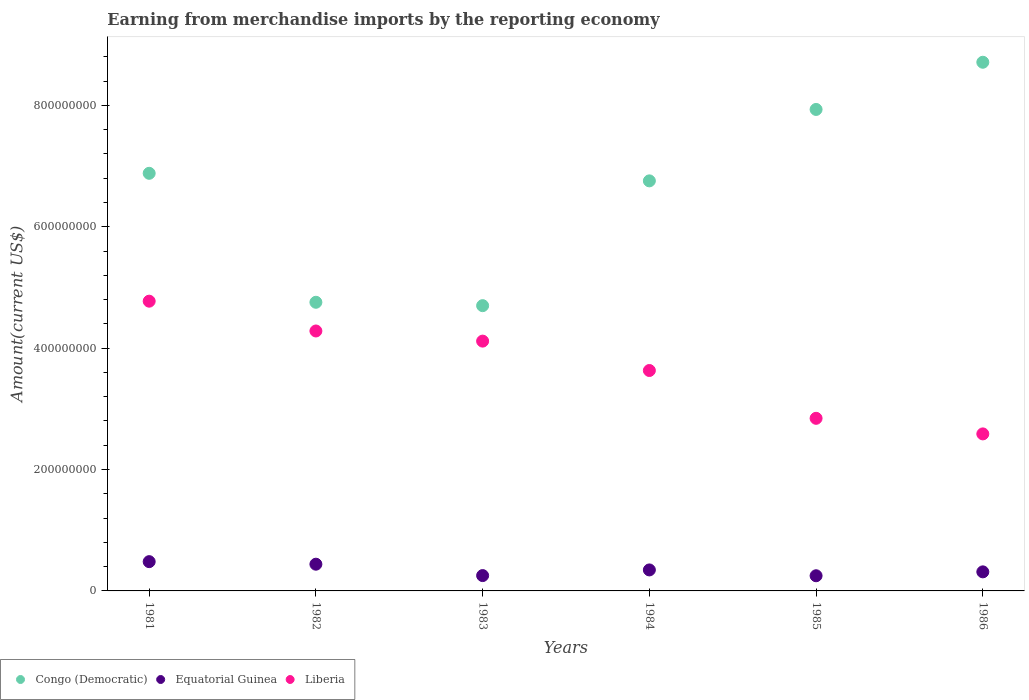Is the number of dotlines equal to the number of legend labels?
Give a very brief answer. Yes. What is the amount earned from merchandise imports in Liberia in 1984?
Your answer should be very brief. 3.63e+08. Across all years, what is the maximum amount earned from merchandise imports in Equatorial Guinea?
Keep it short and to the point. 4.82e+07. Across all years, what is the minimum amount earned from merchandise imports in Liberia?
Offer a terse response. 2.59e+08. In which year was the amount earned from merchandise imports in Equatorial Guinea maximum?
Offer a terse response. 1981. In which year was the amount earned from merchandise imports in Liberia minimum?
Keep it short and to the point. 1986. What is the total amount earned from merchandise imports in Liberia in the graph?
Your response must be concise. 2.22e+09. What is the difference between the amount earned from merchandise imports in Liberia in 1982 and that in 1985?
Your answer should be compact. 1.44e+08. What is the difference between the amount earned from merchandise imports in Equatorial Guinea in 1985 and the amount earned from merchandise imports in Congo (Democratic) in 1981?
Your response must be concise. -6.63e+08. What is the average amount earned from merchandise imports in Equatorial Guinea per year?
Your response must be concise. 3.48e+07. In the year 1983, what is the difference between the amount earned from merchandise imports in Liberia and amount earned from merchandise imports in Equatorial Guinea?
Your response must be concise. 3.86e+08. What is the ratio of the amount earned from merchandise imports in Liberia in 1983 to that in 1984?
Your answer should be compact. 1.13. What is the difference between the highest and the second highest amount earned from merchandise imports in Equatorial Guinea?
Your answer should be compact. 4.21e+06. What is the difference between the highest and the lowest amount earned from merchandise imports in Congo (Democratic)?
Keep it short and to the point. 4.01e+08. Is the sum of the amount earned from merchandise imports in Equatorial Guinea in 1982 and 1983 greater than the maximum amount earned from merchandise imports in Liberia across all years?
Provide a succinct answer. No. Is it the case that in every year, the sum of the amount earned from merchandise imports in Liberia and amount earned from merchandise imports in Congo (Democratic)  is greater than the amount earned from merchandise imports in Equatorial Guinea?
Give a very brief answer. Yes. Does the amount earned from merchandise imports in Equatorial Guinea monotonically increase over the years?
Offer a very short reply. No. Is the amount earned from merchandise imports in Equatorial Guinea strictly greater than the amount earned from merchandise imports in Liberia over the years?
Provide a succinct answer. No. How many dotlines are there?
Offer a very short reply. 3. Does the graph contain grids?
Offer a very short reply. No. Where does the legend appear in the graph?
Offer a terse response. Bottom left. How many legend labels are there?
Your answer should be compact. 3. How are the legend labels stacked?
Offer a terse response. Horizontal. What is the title of the graph?
Your response must be concise. Earning from merchandise imports by the reporting economy. What is the label or title of the Y-axis?
Offer a very short reply. Amount(current US$). What is the Amount(current US$) in Congo (Democratic) in 1981?
Give a very brief answer. 6.88e+08. What is the Amount(current US$) in Equatorial Guinea in 1981?
Provide a succinct answer. 4.82e+07. What is the Amount(current US$) in Liberia in 1981?
Your response must be concise. 4.77e+08. What is the Amount(current US$) of Congo (Democratic) in 1982?
Give a very brief answer. 4.76e+08. What is the Amount(current US$) in Equatorial Guinea in 1982?
Your response must be concise. 4.40e+07. What is the Amount(current US$) in Liberia in 1982?
Make the answer very short. 4.28e+08. What is the Amount(current US$) in Congo (Democratic) in 1983?
Keep it short and to the point. 4.70e+08. What is the Amount(current US$) in Equatorial Guinea in 1983?
Keep it short and to the point. 2.53e+07. What is the Amount(current US$) of Liberia in 1983?
Offer a terse response. 4.12e+08. What is the Amount(current US$) in Congo (Democratic) in 1984?
Provide a short and direct response. 6.76e+08. What is the Amount(current US$) of Equatorial Guinea in 1984?
Your answer should be very brief. 3.46e+07. What is the Amount(current US$) of Liberia in 1984?
Ensure brevity in your answer.  3.63e+08. What is the Amount(current US$) of Congo (Democratic) in 1985?
Offer a terse response. 7.93e+08. What is the Amount(current US$) in Equatorial Guinea in 1985?
Give a very brief answer. 2.50e+07. What is the Amount(current US$) in Liberia in 1985?
Make the answer very short. 2.84e+08. What is the Amount(current US$) of Congo (Democratic) in 1986?
Offer a very short reply. 8.71e+08. What is the Amount(current US$) in Equatorial Guinea in 1986?
Your response must be concise. 3.14e+07. What is the Amount(current US$) in Liberia in 1986?
Your answer should be compact. 2.59e+08. Across all years, what is the maximum Amount(current US$) in Congo (Democratic)?
Provide a short and direct response. 8.71e+08. Across all years, what is the maximum Amount(current US$) in Equatorial Guinea?
Your answer should be very brief. 4.82e+07. Across all years, what is the maximum Amount(current US$) in Liberia?
Offer a terse response. 4.77e+08. Across all years, what is the minimum Amount(current US$) of Congo (Democratic)?
Your answer should be very brief. 4.70e+08. Across all years, what is the minimum Amount(current US$) in Equatorial Guinea?
Your answer should be compact. 2.50e+07. Across all years, what is the minimum Amount(current US$) of Liberia?
Your response must be concise. 2.59e+08. What is the total Amount(current US$) of Congo (Democratic) in the graph?
Make the answer very short. 3.97e+09. What is the total Amount(current US$) in Equatorial Guinea in the graph?
Provide a short and direct response. 2.09e+08. What is the total Amount(current US$) of Liberia in the graph?
Offer a very short reply. 2.22e+09. What is the difference between the Amount(current US$) in Congo (Democratic) in 1981 and that in 1982?
Provide a succinct answer. 2.12e+08. What is the difference between the Amount(current US$) in Equatorial Guinea in 1981 and that in 1982?
Offer a very short reply. 4.21e+06. What is the difference between the Amount(current US$) in Liberia in 1981 and that in 1982?
Your answer should be compact. 4.91e+07. What is the difference between the Amount(current US$) in Congo (Democratic) in 1981 and that in 1983?
Keep it short and to the point. 2.18e+08. What is the difference between the Amount(current US$) in Equatorial Guinea in 1981 and that in 1983?
Give a very brief answer. 2.30e+07. What is the difference between the Amount(current US$) of Liberia in 1981 and that in 1983?
Your answer should be very brief. 6.58e+07. What is the difference between the Amount(current US$) of Congo (Democratic) in 1981 and that in 1984?
Make the answer very short. 1.24e+07. What is the difference between the Amount(current US$) in Equatorial Guinea in 1981 and that in 1984?
Ensure brevity in your answer.  1.37e+07. What is the difference between the Amount(current US$) in Liberia in 1981 and that in 1984?
Offer a very short reply. 1.14e+08. What is the difference between the Amount(current US$) in Congo (Democratic) in 1981 and that in 1985?
Provide a succinct answer. -1.05e+08. What is the difference between the Amount(current US$) of Equatorial Guinea in 1981 and that in 1985?
Your answer should be compact. 2.33e+07. What is the difference between the Amount(current US$) in Liberia in 1981 and that in 1985?
Your answer should be compact. 1.93e+08. What is the difference between the Amount(current US$) in Congo (Democratic) in 1981 and that in 1986?
Ensure brevity in your answer.  -1.83e+08. What is the difference between the Amount(current US$) in Equatorial Guinea in 1981 and that in 1986?
Offer a terse response. 1.68e+07. What is the difference between the Amount(current US$) of Liberia in 1981 and that in 1986?
Your answer should be compact. 2.19e+08. What is the difference between the Amount(current US$) of Congo (Democratic) in 1982 and that in 1983?
Ensure brevity in your answer.  5.57e+06. What is the difference between the Amount(current US$) in Equatorial Guinea in 1982 and that in 1983?
Your answer should be compact. 1.88e+07. What is the difference between the Amount(current US$) in Liberia in 1982 and that in 1983?
Make the answer very short. 1.67e+07. What is the difference between the Amount(current US$) of Congo (Democratic) in 1982 and that in 1984?
Your response must be concise. -2.00e+08. What is the difference between the Amount(current US$) of Equatorial Guinea in 1982 and that in 1984?
Offer a terse response. 9.44e+06. What is the difference between the Amount(current US$) in Liberia in 1982 and that in 1984?
Give a very brief answer. 6.51e+07. What is the difference between the Amount(current US$) in Congo (Democratic) in 1982 and that in 1985?
Keep it short and to the point. -3.18e+08. What is the difference between the Amount(current US$) of Equatorial Guinea in 1982 and that in 1985?
Your answer should be very brief. 1.90e+07. What is the difference between the Amount(current US$) in Liberia in 1982 and that in 1985?
Offer a terse response. 1.44e+08. What is the difference between the Amount(current US$) of Congo (Democratic) in 1982 and that in 1986?
Provide a succinct answer. -3.95e+08. What is the difference between the Amount(current US$) of Equatorial Guinea in 1982 and that in 1986?
Provide a succinct answer. 1.26e+07. What is the difference between the Amount(current US$) of Liberia in 1982 and that in 1986?
Your response must be concise. 1.70e+08. What is the difference between the Amount(current US$) of Congo (Democratic) in 1983 and that in 1984?
Give a very brief answer. -2.06e+08. What is the difference between the Amount(current US$) of Equatorial Guinea in 1983 and that in 1984?
Offer a terse response. -9.32e+06. What is the difference between the Amount(current US$) in Liberia in 1983 and that in 1984?
Your answer should be very brief. 4.84e+07. What is the difference between the Amount(current US$) in Congo (Democratic) in 1983 and that in 1985?
Your answer should be compact. -3.23e+08. What is the difference between the Amount(current US$) in Equatorial Guinea in 1983 and that in 1985?
Offer a very short reply. 2.85e+05. What is the difference between the Amount(current US$) in Liberia in 1983 and that in 1985?
Ensure brevity in your answer.  1.27e+08. What is the difference between the Amount(current US$) in Congo (Democratic) in 1983 and that in 1986?
Give a very brief answer. -4.01e+08. What is the difference between the Amount(current US$) of Equatorial Guinea in 1983 and that in 1986?
Make the answer very short. -6.14e+06. What is the difference between the Amount(current US$) of Liberia in 1983 and that in 1986?
Keep it short and to the point. 1.53e+08. What is the difference between the Amount(current US$) in Congo (Democratic) in 1984 and that in 1985?
Give a very brief answer. -1.18e+08. What is the difference between the Amount(current US$) of Equatorial Guinea in 1984 and that in 1985?
Keep it short and to the point. 9.60e+06. What is the difference between the Amount(current US$) of Liberia in 1984 and that in 1985?
Your answer should be compact. 7.88e+07. What is the difference between the Amount(current US$) of Congo (Democratic) in 1984 and that in 1986?
Your response must be concise. -1.95e+08. What is the difference between the Amount(current US$) of Equatorial Guinea in 1984 and that in 1986?
Offer a very short reply. 3.18e+06. What is the difference between the Amount(current US$) of Liberia in 1984 and that in 1986?
Give a very brief answer. 1.04e+08. What is the difference between the Amount(current US$) in Congo (Democratic) in 1985 and that in 1986?
Your answer should be compact. -7.78e+07. What is the difference between the Amount(current US$) in Equatorial Guinea in 1985 and that in 1986?
Your answer should be compact. -6.42e+06. What is the difference between the Amount(current US$) of Liberia in 1985 and that in 1986?
Offer a terse response. 2.57e+07. What is the difference between the Amount(current US$) of Congo (Democratic) in 1981 and the Amount(current US$) of Equatorial Guinea in 1982?
Provide a succinct answer. 6.44e+08. What is the difference between the Amount(current US$) of Congo (Democratic) in 1981 and the Amount(current US$) of Liberia in 1982?
Offer a terse response. 2.60e+08. What is the difference between the Amount(current US$) in Equatorial Guinea in 1981 and the Amount(current US$) in Liberia in 1982?
Provide a short and direct response. -3.80e+08. What is the difference between the Amount(current US$) in Congo (Democratic) in 1981 and the Amount(current US$) in Equatorial Guinea in 1983?
Your response must be concise. 6.63e+08. What is the difference between the Amount(current US$) of Congo (Democratic) in 1981 and the Amount(current US$) of Liberia in 1983?
Make the answer very short. 2.77e+08. What is the difference between the Amount(current US$) of Equatorial Guinea in 1981 and the Amount(current US$) of Liberia in 1983?
Offer a terse response. -3.63e+08. What is the difference between the Amount(current US$) of Congo (Democratic) in 1981 and the Amount(current US$) of Equatorial Guinea in 1984?
Offer a terse response. 6.54e+08. What is the difference between the Amount(current US$) in Congo (Democratic) in 1981 and the Amount(current US$) in Liberia in 1984?
Give a very brief answer. 3.25e+08. What is the difference between the Amount(current US$) of Equatorial Guinea in 1981 and the Amount(current US$) of Liberia in 1984?
Offer a terse response. -3.15e+08. What is the difference between the Amount(current US$) of Congo (Democratic) in 1981 and the Amount(current US$) of Equatorial Guinea in 1985?
Your answer should be very brief. 6.63e+08. What is the difference between the Amount(current US$) in Congo (Democratic) in 1981 and the Amount(current US$) in Liberia in 1985?
Make the answer very short. 4.04e+08. What is the difference between the Amount(current US$) in Equatorial Guinea in 1981 and the Amount(current US$) in Liberia in 1985?
Offer a terse response. -2.36e+08. What is the difference between the Amount(current US$) of Congo (Democratic) in 1981 and the Amount(current US$) of Equatorial Guinea in 1986?
Ensure brevity in your answer.  6.57e+08. What is the difference between the Amount(current US$) of Congo (Democratic) in 1981 and the Amount(current US$) of Liberia in 1986?
Keep it short and to the point. 4.29e+08. What is the difference between the Amount(current US$) in Equatorial Guinea in 1981 and the Amount(current US$) in Liberia in 1986?
Your answer should be very brief. -2.10e+08. What is the difference between the Amount(current US$) in Congo (Democratic) in 1982 and the Amount(current US$) in Equatorial Guinea in 1983?
Your response must be concise. 4.50e+08. What is the difference between the Amount(current US$) of Congo (Democratic) in 1982 and the Amount(current US$) of Liberia in 1983?
Keep it short and to the point. 6.40e+07. What is the difference between the Amount(current US$) in Equatorial Guinea in 1982 and the Amount(current US$) in Liberia in 1983?
Offer a terse response. -3.68e+08. What is the difference between the Amount(current US$) of Congo (Democratic) in 1982 and the Amount(current US$) of Equatorial Guinea in 1984?
Offer a terse response. 4.41e+08. What is the difference between the Amount(current US$) of Congo (Democratic) in 1982 and the Amount(current US$) of Liberia in 1984?
Your answer should be very brief. 1.12e+08. What is the difference between the Amount(current US$) of Equatorial Guinea in 1982 and the Amount(current US$) of Liberia in 1984?
Your response must be concise. -3.19e+08. What is the difference between the Amount(current US$) of Congo (Democratic) in 1982 and the Amount(current US$) of Equatorial Guinea in 1985?
Provide a succinct answer. 4.51e+08. What is the difference between the Amount(current US$) of Congo (Democratic) in 1982 and the Amount(current US$) of Liberia in 1985?
Provide a succinct answer. 1.91e+08. What is the difference between the Amount(current US$) of Equatorial Guinea in 1982 and the Amount(current US$) of Liberia in 1985?
Offer a very short reply. -2.40e+08. What is the difference between the Amount(current US$) in Congo (Democratic) in 1982 and the Amount(current US$) in Equatorial Guinea in 1986?
Provide a short and direct response. 4.44e+08. What is the difference between the Amount(current US$) of Congo (Democratic) in 1982 and the Amount(current US$) of Liberia in 1986?
Offer a very short reply. 2.17e+08. What is the difference between the Amount(current US$) of Equatorial Guinea in 1982 and the Amount(current US$) of Liberia in 1986?
Ensure brevity in your answer.  -2.15e+08. What is the difference between the Amount(current US$) of Congo (Democratic) in 1983 and the Amount(current US$) of Equatorial Guinea in 1984?
Offer a very short reply. 4.35e+08. What is the difference between the Amount(current US$) in Congo (Democratic) in 1983 and the Amount(current US$) in Liberia in 1984?
Give a very brief answer. 1.07e+08. What is the difference between the Amount(current US$) in Equatorial Guinea in 1983 and the Amount(current US$) in Liberia in 1984?
Make the answer very short. -3.38e+08. What is the difference between the Amount(current US$) of Congo (Democratic) in 1983 and the Amount(current US$) of Equatorial Guinea in 1985?
Offer a very short reply. 4.45e+08. What is the difference between the Amount(current US$) of Congo (Democratic) in 1983 and the Amount(current US$) of Liberia in 1985?
Provide a short and direct response. 1.86e+08. What is the difference between the Amount(current US$) in Equatorial Guinea in 1983 and the Amount(current US$) in Liberia in 1985?
Your response must be concise. -2.59e+08. What is the difference between the Amount(current US$) in Congo (Democratic) in 1983 and the Amount(current US$) in Equatorial Guinea in 1986?
Ensure brevity in your answer.  4.39e+08. What is the difference between the Amount(current US$) in Congo (Democratic) in 1983 and the Amount(current US$) in Liberia in 1986?
Provide a succinct answer. 2.11e+08. What is the difference between the Amount(current US$) in Equatorial Guinea in 1983 and the Amount(current US$) in Liberia in 1986?
Offer a terse response. -2.33e+08. What is the difference between the Amount(current US$) in Congo (Democratic) in 1984 and the Amount(current US$) in Equatorial Guinea in 1985?
Offer a terse response. 6.51e+08. What is the difference between the Amount(current US$) of Congo (Democratic) in 1984 and the Amount(current US$) of Liberia in 1985?
Keep it short and to the point. 3.91e+08. What is the difference between the Amount(current US$) in Equatorial Guinea in 1984 and the Amount(current US$) in Liberia in 1985?
Provide a short and direct response. -2.50e+08. What is the difference between the Amount(current US$) of Congo (Democratic) in 1984 and the Amount(current US$) of Equatorial Guinea in 1986?
Your response must be concise. 6.44e+08. What is the difference between the Amount(current US$) in Congo (Democratic) in 1984 and the Amount(current US$) in Liberia in 1986?
Provide a short and direct response. 4.17e+08. What is the difference between the Amount(current US$) in Equatorial Guinea in 1984 and the Amount(current US$) in Liberia in 1986?
Ensure brevity in your answer.  -2.24e+08. What is the difference between the Amount(current US$) of Congo (Democratic) in 1985 and the Amount(current US$) of Equatorial Guinea in 1986?
Offer a very short reply. 7.62e+08. What is the difference between the Amount(current US$) in Congo (Democratic) in 1985 and the Amount(current US$) in Liberia in 1986?
Your answer should be very brief. 5.35e+08. What is the difference between the Amount(current US$) of Equatorial Guinea in 1985 and the Amount(current US$) of Liberia in 1986?
Ensure brevity in your answer.  -2.34e+08. What is the average Amount(current US$) in Congo (Democratic) per year?
Offer a very short reply. 6.62e+08. What is the average Amount(current US$) in Equatorial Guinea per year?
Provide a short and direct response. 3.48e+07. What is the average Amount(current US$) of Liberia per year?
Keep it short and to the point. 3.71e+08. In the year 1981, what is the difference between the Amount(current US$) in Congo (Democratic) and Amount(current US$) in Equatorial Guinea?
Provide a short and direct response. 6.40e+08. In the year 1981, what is the difference between the Amount(current US$) in Congo (Democratic) and Amount(current US$) in Liberia?
Keep it short and to the point. 2.11e+08. In the year 1981, what is the difference between the Amount(current US$) of Equatorial Guinea and Amount(current US$) of Liberia?
Offer a terse response. -4.29e+08. In the year 1982, what is the difference between the Amount(current US$) in Congo (Democratic) and Amount(current US$) in Equatorial Guinea?
Provide a short and direct response. 4.32e+08. In the year 1982, what is the difference between the Amount(current US$) in Congo (Democratic) and Amount(current US$) in Liberia?
Make the answer very short. 4.73e+07. In the year 1982, what is the difference between the Amount(current US$) of Equatorial Guinea and Amount(current US$) of Liberia?
Offer a terse response. -3.84e+08. In the year 1983, what is the difference between the Amount(current US$) in Congo (Democratic) and Amount(current US$) in Equatorial Guinea?
Keep it short and to the point. 4.45e+08. In the year 1983, what is the difference between the Amount(current US$) of Congo (Democratic) and Amount(current US$) of Liberia?
Provide a succinct answer. 5.84e+07. In the year 1983, what is the difference between the Amount(current US$) of Equatorial Guinea and Amount(current US$) of Liberia?
Offer a terse response. -3.86e+08. In the year 1984, what is the difference between the Amount(current US$) of Congo (Democratic) and Amount(current US$) of Equatorial Guinea?
Your answer should be very brief. 6.41e+08. In the year 1984, what is the difference between the Amount(current US$) in Congo (Democratic) and Amount(current US$) in Liberia?
Provide a succinct answer. 3.12e+08. In the year 1984, what is the difference between the Amount(current US$) in Equatorial Guinea and Amount(current US$) in Liberia?
Your response must be concise. -3.29e+08. In the year 1985, what is the difference between the Amount(current US$) of Congo (Democratic) and Amount(current US$) of Equatorial Guinea?
Provide a short and direct response. 7.68e+08. In the year 1985, what is the difference between the Amount(current US$) of Congo (Democratic) and Amount(current US$) of Liberia?
Ensure brevity in your answer.  5.09e+08. In the year 1985, what is the difference between the Amount(current US$) in Equatorial Guinea and Amount(current US$) in Liberia?
Give a very brief answer. -2.59e+08. In the year 1986, what is the difference between the Amount(current US$) of Congo (Democratic) and Amount(current US$) of Equatorial Guinea?
Offer a terse response. 8.40e+08. In the year 1986, what is the difference between the Amount(current US$) in Congo (Democratic) and Amount(current US$) in Liberia?
Provide a short and direct response. 6.12e+08. In the year 1986, what is the difference between the Amount(current US$) of Equatorial Guinea and Amount(current US$) of Liberia?
Provide a short and direct response. -2.27e+08. What is the ratio of the Amount(current US$) in Congo (Democratic) in 1981 to that in 1982?
Give a very brief answer. 1.45. What is the ratio of the Amount(current US$) in Equatorial Guinea in 1981 to that in 1982?
Offer a terse response. 1.1. What is the ratio of the Amount(current US$) in Liberia in 1981 to that in 1982?
Provide a succinct answer. 1.11. What is the ratio of the Amount(current US$) in Congo (Democratic) in 1981 to that in 1983?
Offer a terse response. 1.46. What is the ratio of the Amount(current US$) in Equatorial Guinea in 1981 to that in 1983?
Offer a terse response. 1.91. What is the ratio of the Amount(current US$) of Liberia in 1981 to that in 1983?
Give a very brief answer. 1.16. What is the ratio of the Amount(current US$) of Congo (Democratic) in 1981 to that in 1984?
Offer a very short reply. 1.02. What is the ratio of the Amount(current US$) of Equatorial Guinea in 1981 to that in 1984?
Your response must be concise. 1.39. What is the ratio of the Amount(current US$) of Liberia in 1981 to that in 1984?
Keep it short and to the point. 1.31. What is the ratio of the Amount(current US$) in Congo (Democratic) in 1981 to that in 1985?
Offer a terse response. 0.87. What is the ratio of the Amount(current US$) in Equatorial Guinea in 1981 to that in 1985?
Your answer should be compact. 1.93. What is the ratio of the Amount(current US$) of Liberia in 1981 to that in 1985?
Your response must be concise. 1.68. What is the ratio of the Amount(current US$) of Congo (Democratic) in 1981 to that in 1986?
Your answer should be compact. 0.79. What is the ratio of the Amount(current US$) of Equatorial Guinea in 1981 to that in 1986?
Give a very brief answer. 1.54. What is the ratio of the Amount(current US$) in Liberia in 1981 to that in 1986?
Ensure brevity in your answer.  1.85. What is the ratio of the Amount(current US$) of Congo (Democratic) in 1982 to that in 1983?
Offer a terse response. 1.01. What is the ratio of the Amount(current US$) of Equatorial Guinea in 1982 to that in 1983?
Your response must be concise. 1.74. What is the ratio of the Amount(current US$) of Liberia in 1982 to that in 1983?
Ensure brevity in your answer.  1.04. What is the ratio of the Amount(current US$) in Congo (Democratic) in 1982 to that in 1984?
Provide a succinct answer. 0.7. What is the ratio of the Amount(current US$) of Equatorial Guinea in 1982 to that in 1984?
Make the answer very short. 1.27. What is the ratio of the Amount(current US$) in Liberia in 1982 to that in 1984?
Ensure brevity in your answer.  1.18. What is the ratio of the Amount(current US$) of Congo (Democratic) in 1982 to that in 1985?
Your response must be concise. 0.6. What is the ratio of the Amount(current US$) in Equatorial Guinea in 1982 to that in 1985?
Give a very brief answer. 1.76. What is the ratio of the Amount(current US$) of Liberia in 1982 to that in 1985?
Ensure brevity in your answer.  1.51. What is the ratio of the Amount(current US$) of Congo (Democratic) in 1982 to that in 1986?
Provide a short and direct response. 0.55. What is the ratio of the Amount(current US$) of Equatorial Guinea in 1982 to that in 1986?
Offer a very short reply. 1.4. What is the ratio of the Amount(current US$) in Liberia in 1982 to that in 1986?
Provide a short and direct response. 1.66. What is the ratio of the Amount(current US$) of Congo (Democratic) in 1983 to that in 1984?
Provide a short and direct response. 0.7. What is the ratio of the Amount(current US$) of Equatorial Guinea in 1983 to that in 1984?
Make the answer very short. 0.73. What is the ratio of the Amount(current US$) of Liberia in 1983 to that in 1984?
Your answer should be very brief. 1.13. What is the ratio of the Amount(current US$) in Congo (Democratic) in 1983 to that in 1985?
Offer a terse response. 0.59. What is the ratio of the Amount(current US$) of Equatorial Guinea in 1983 to that in 1985?
Your answer should be very brief. 1.01. What is the ratio of the Amount(current US$) in Liberia in 1983 to that in 1985?
Offer a very short reply. 1.45. What is the ratio of the Amount(current US$) of Congo (Democratic) in 1983 to that in 1986?
Offer a very short reply. 0.54. What is the ratio of the Amount(current US$) in Equatorial Guinea in 1983 to that in 1986?
Your answer should be compact. 0.8. What is the ratio of the Amount(current US$) of Liberia in 1983 to that in 1986?
Give a very brief answer. 1.59. What is the ratio of the Amount(current US$) in Congo (Democratic) in 1984 to that in 1985?
Provide a succinct answer. 0.85. What is the ratio of the Amount(current US$) of Equatorial Guinea in 1984 to that in 1985?
Your response must be concise. 1.38. What is the ratio of the Amount(current US$) in Liberia in 1984 to that in 1985?
Provide a succinct answer. 1.28. What is the ratio of the Amount(current US$) in Congo (Democratic) in 1984 to that in 1986?
Give a very brief answer. 0.78. What is the ratio of the Amount(current US$) in Equatorial Guinea in 1984 to that in 1986?
Offer a very short reply. 1.1. What is the ratio of the Amount(current US$) of Liberia in 1984 to that in 1986?
Your answer should be very brief. 1.4. What is the ratio of the Amount(current US$) of Congo (Democratic) in 1985 to that in 1986?
Ensure brevity in your answer.  0.91. What is the ratio of the Amount(current US$) of Equatorial Guinea in 1985 to that in 1986?
Ensure brevity in your answer.  0.8. What is the ratio of the Amount(current US$) in Liberia in 1985 to that in 1986?
Make the answer very short. 1.1. What is the difference between the highest and the second highest Amount(current US$) of Congo (Democratic)?
Your answer should be very brief. 7.78e+07. What is the difference between the highest and the second highest Amount(current US$) in Equatorial Guinea?
Your answer should be compact. 4.21e+06. What is the difference between the highest and the second highest Amount(current US$) of Liberia?
Offer a terse response. 4.91e+07. What is the difference between the highest and the lowest Amount(current US$) in Congo (Democratic)?
Offer a very short reply. 4.01e+08. What is the difference between the highest and the lowest Amount(current US$) in Equatorial Guinea?
Offer a very short reply. 2.33e+07. What is the difference between the highest and the lowest Amount(current US$) in Liberia?
Your answer should be compact. 2.19e+08. 